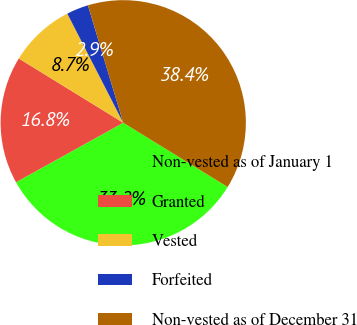Convert chart. <chart><loc_0><loc_0><loc_500><loc_500><pie_chart><fcel>Non-vested as of January 1<fcel>Granted<fcel>Vested<fcel>Forfeited<fcel>Non-vested as of December 31<nl><fcel>33.16%<fcel>16.84%<fcel>8.68%<fcel>2.89%<fcel>38.42%<nl></chart> 